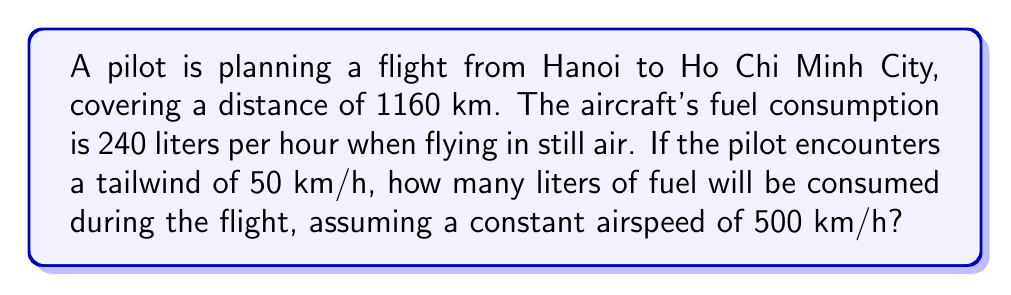Provide a solution to this math problem. Let's approach this step-by-step:

1) First, we need to calculate the ground speed of the aircraft:
   Ground speed = Airspeed + Tailwind
   $$ 500 \text{ km/h} + 50 \text{ km/h} = 550 \text{ km/h} $$

2) Now, we can calculate the flight time:
   $$ \text{Time} = \frac{\text{Distance}}{\text{Ground Speed}} = \frac{1160 \text{ km}}{550 \text{ km/h}} = \frac{58}{27.5} \text{ hours} \approx 2.109 \text{ hours} $$

3) Given that the fuel consumption is 240 liters per hour, we can calculate the total fuel consumed:
   $$ \text{Fuel Consumed} = \text{Fuel Consumption Rate} \times \text{Time} $$
   $$ = 240 \text{ L/h} \times 2.109 \text{ h} = 506.16 \text{ L} $$

4) Rounding to the nearest liter:
   $$ 506 \text{ L} $$
Answer: 506 L 